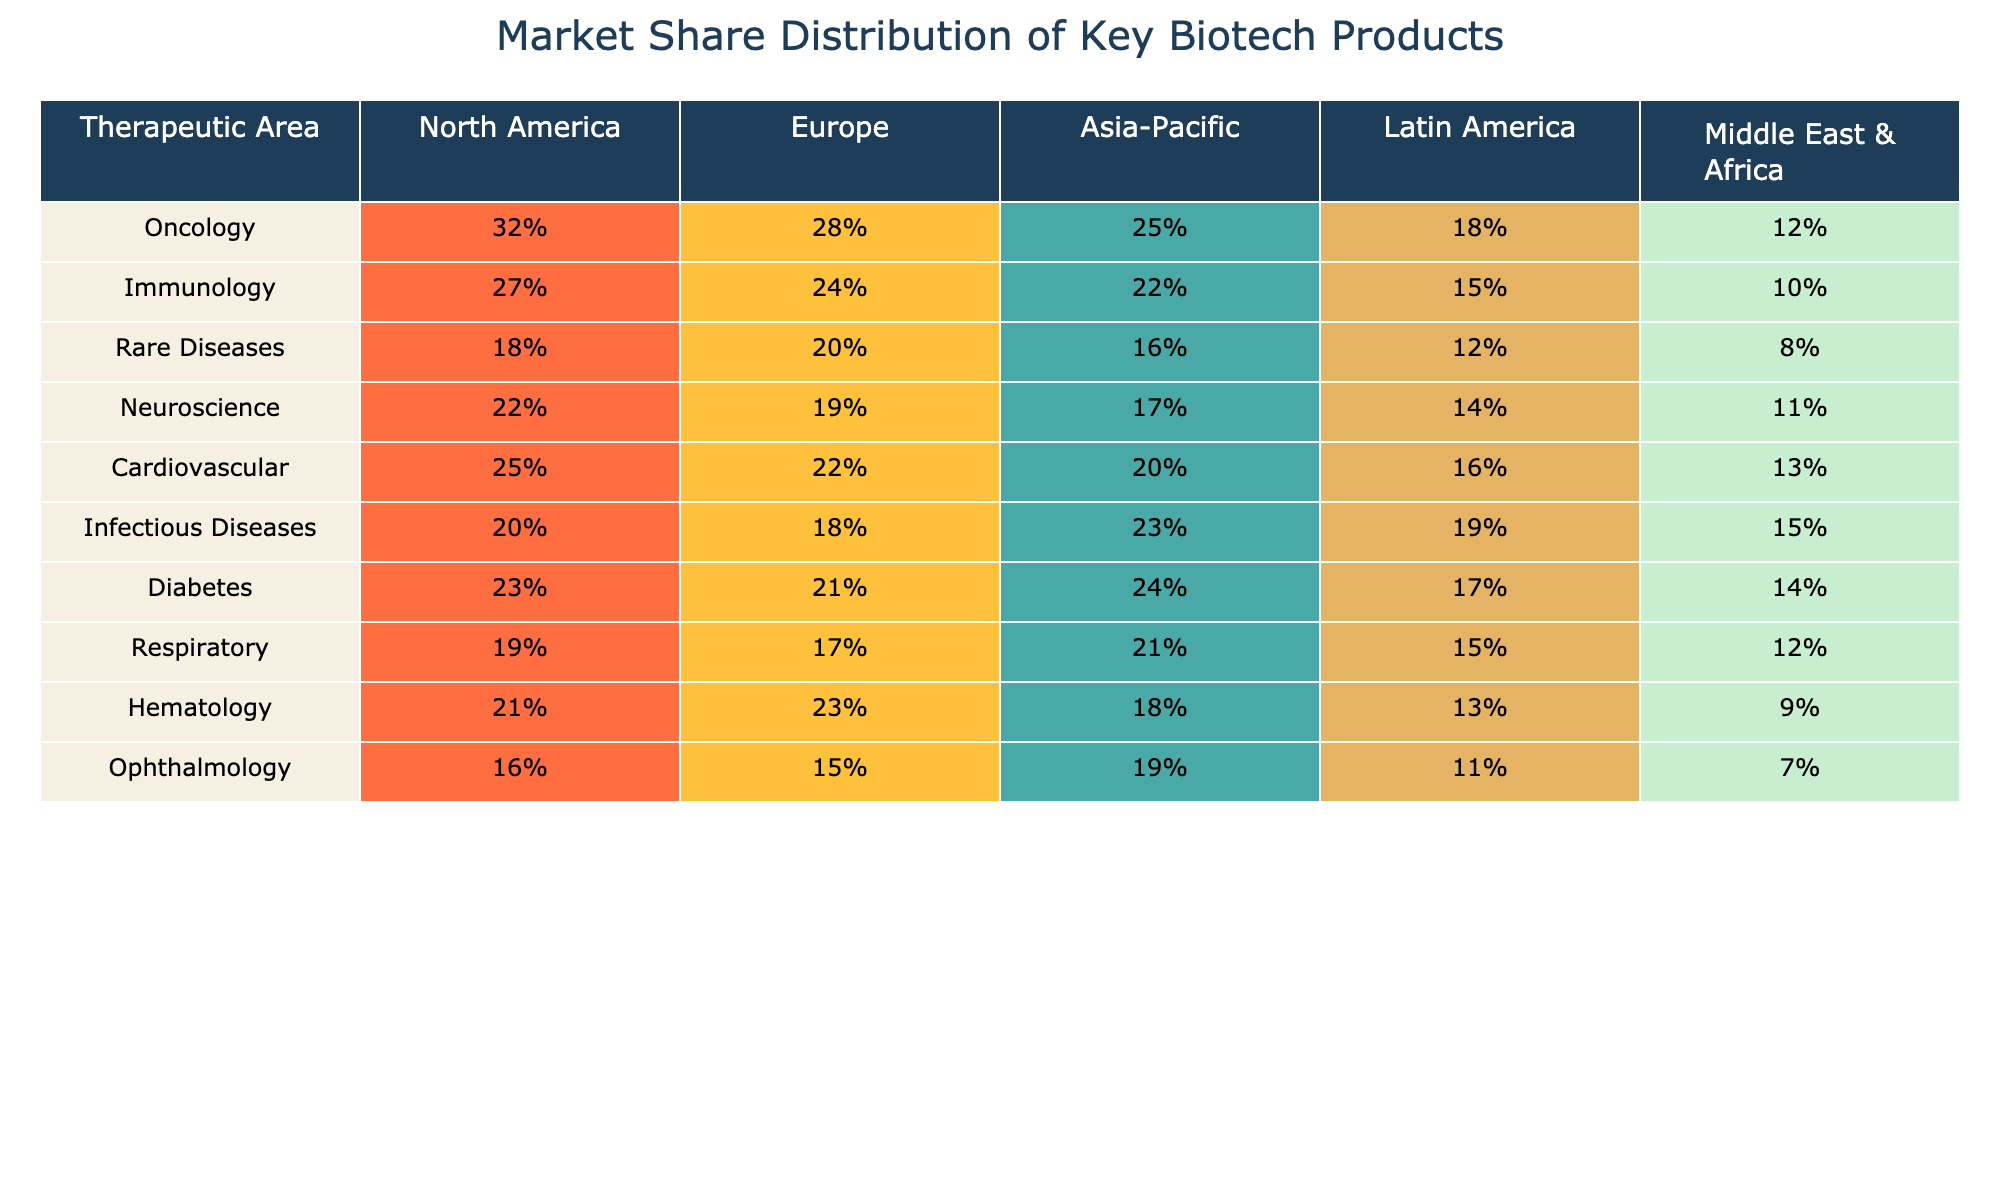What is the highest market share percentage for Oncology in North America? The table shows Oncology has a market share of 32% in North America, which is the highest percentage listed for any therapeutic area in that region.
Answer: 32% Which therapeutic area has the lowest market share in Latin America? In the table, the lowest percentage in Latin America is 12%, which belongs to Rare Diseases and Hematology. The lowest distinct value, however, is 12%.
Answer: 12% What is the average market share for Immunology across all regions? Adding the market shares for Immunology in all regions: (27% + 24% + 22% + 15% + 10%) = 98%. Dividing by 5 regions gives an average of 98% / 5 = 19.6%.
Answer: 19.6% Is the market share for Respiratory higher in Asia-Pacific than in North America? The market share for Respiratory is 21% in Asia-Pacific and 19% in North America. Since 21% is greater than 19%, the statement is true.
Answer: Yes What is the difference in market share for Diabetes between North America and Europe? The market share for Diabetes is 23% in North America and 21% in Europe. The difference is 23% - 21% = 2%.
Answer: 2% Which region has the highest market share for Hematology? The table lists Hematology at 23% in Europe as the highest value among all regions for this therapeutic area.
Answer: 23% If we combine the market shares of Oncology and Immunology in Europe, what is the total? The market shares for Oncology and Immunology in Europe are 28% and 24%, respectively. Adding these gives 28% + 24% = 52%.
Answer: 52% Which therapeutic area has the largest discrepancy between its highest and lowest market share across all regions? By assessing all areas: Oncology (32%-12% = 20%), Immunology (27%-10% = 17%), Rare Diseases (20%-8% = 12%), Neuroscience (22%-11% = 11%), Cardiovascular (25%-13% = 12%), Infectious Diseases (23%-15% = 8%), Diabetes (24%-14% = 10%), and Respiratory (21%-12% = 9%). The largest discrepancy is for Oncology at 20%.
Answer: Oncology What percentage of market share does the Middle East & Africa hold for Infectious Diseases? The table shows the market share for Infectious Diseases in the Middle East & Africa is 15%.
Answer: 15% In which region does Neuroscience have the least market share? The table states that Neuroscience has its lowest market share of 17% in Asia-Pacific.
Answer: Asia-Pacific Which therapeutic area consistently has the highest market share across all regions? Upon reviewing the values, Oncology has the highest percentage across all regions (32%, 28%, 25%, 18%, 12%).
Answer: Oncology 